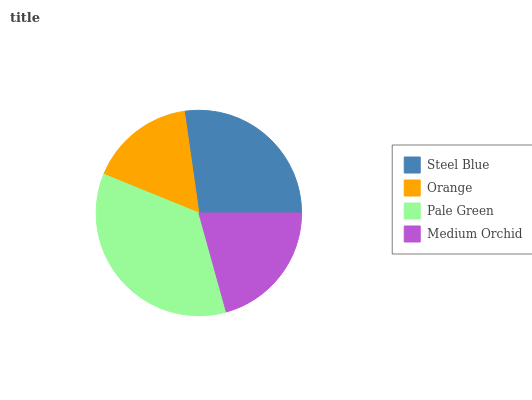Is Orange the minimum?
Answer yes or no. Yes. Is Pale Green the maximum?
Answer yes or no. Yes. Is Pale Green the minimum?
Answer yes or no. No. Is Orange the maximum?
Answer yes or no. No. Is Pale Green greater than Orange?
Answer yes or no. Yes. Is Orange less than Pale Green?
Answer yes or no. Yes. Is Orange greater than Pale Green?
Answer yes or no. No. Is Pale Green less than Orange?
Answer yes or no. No. Is Steel Blue the high median?
Answer yes or no. Yes. Is Medium Orchid the low median?
Answer yes or no. Yes. Is Pale Green the high median?
Answer yes or no. No. Is Pale Green the low median?
Answer yes or no. No. 